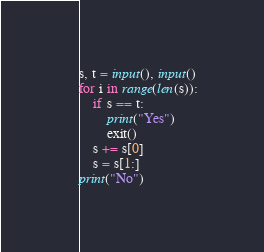Convert code to text. <code><loc_0><loc_0><loc_500><loc_500><_Python_>s, t = input(), input()
for i in range(len(s)):
    if s == t:
        print("Yes")
        exit()
    s += s[0]
    s = s[1:]
print("No")</code> 